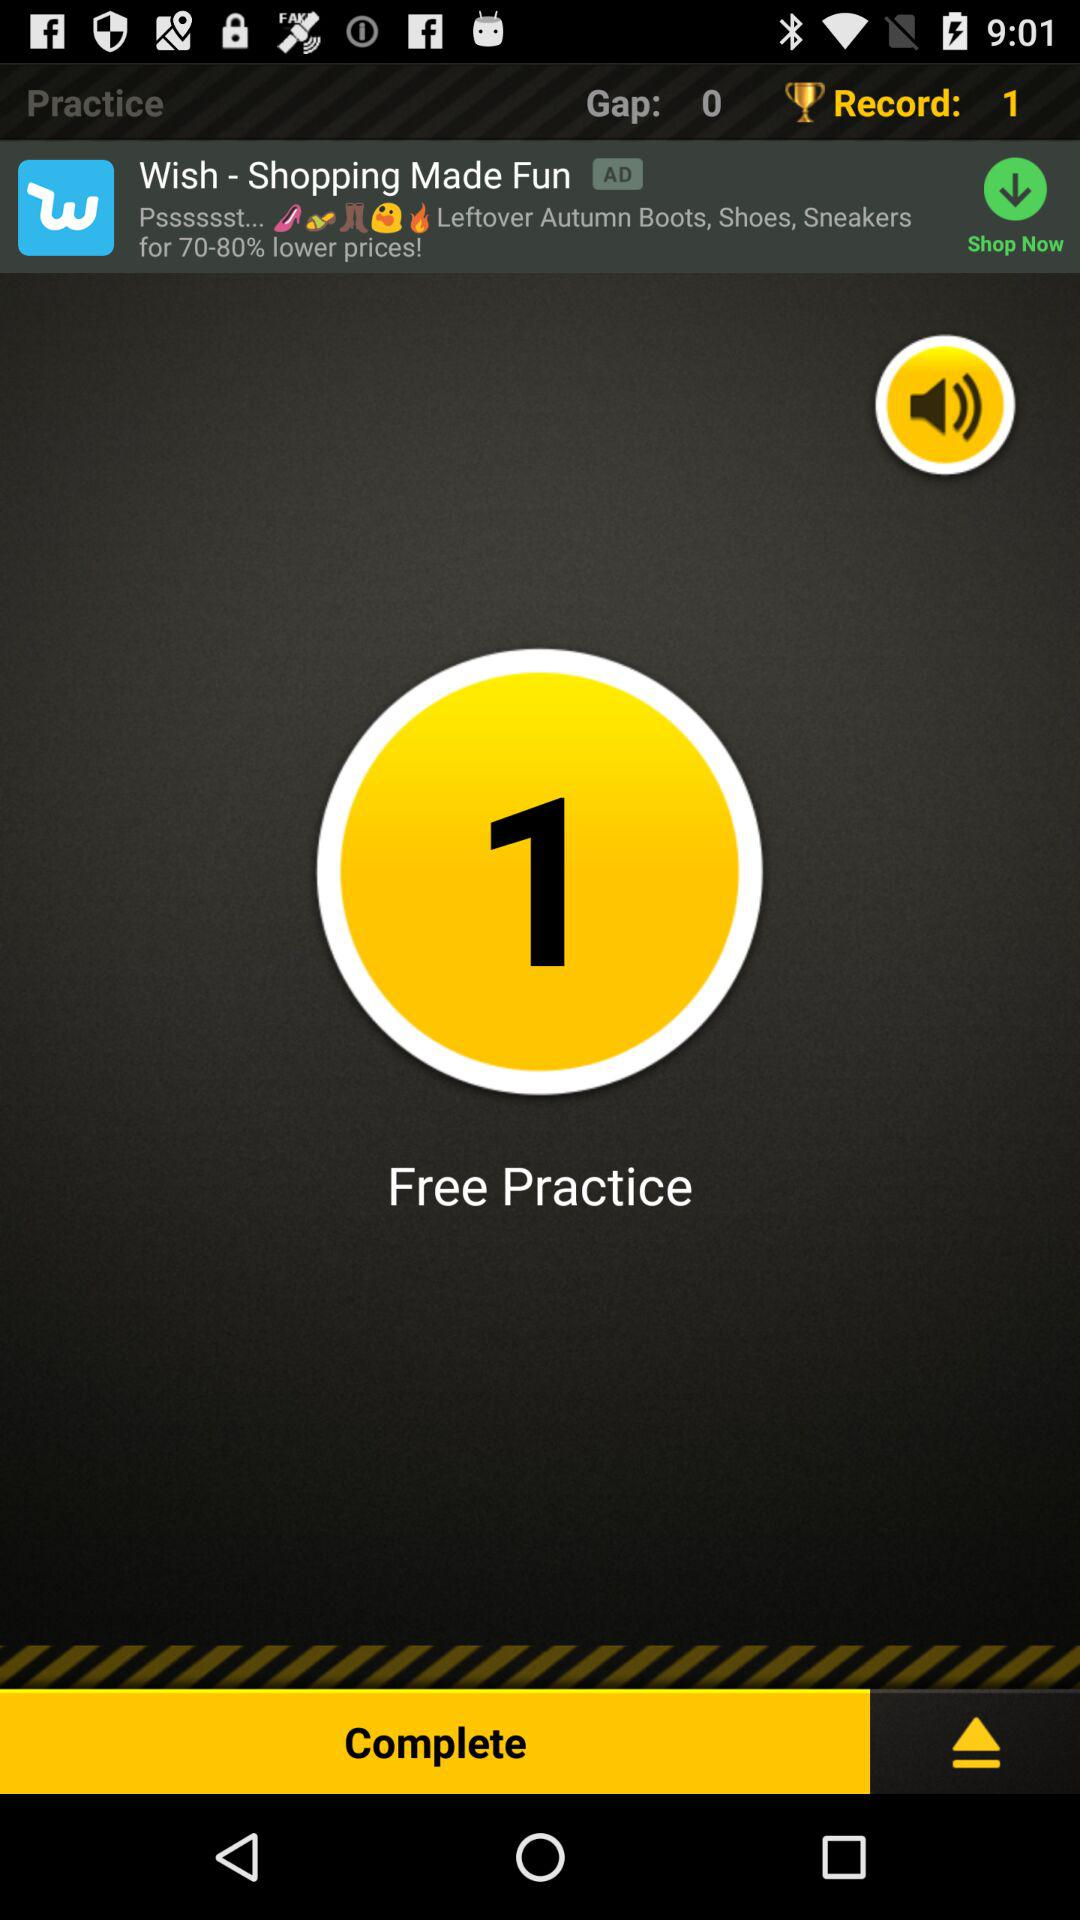How many gaps are there? There are 0 gaps. 